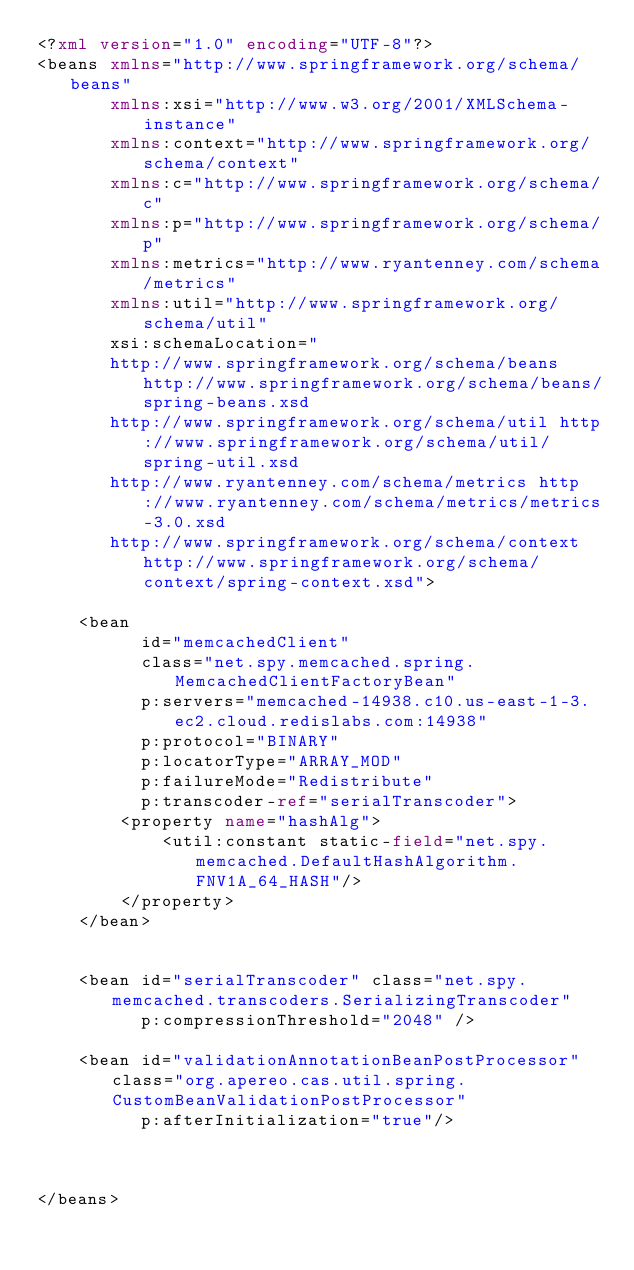Convert code to text. <code><loc_0><loc_0><loc_500><loc_500><_XML_><?xml version="1.0" encoding="UTF-8"?>
<beans xmlns="http://www.springframework.org/schema/beans"
       xmlns:xsi="http://www.w3.org/2001/XMLSchema-instance"
       xmlns:context="http://www.springframework.org/schema/context"
       xmlns:c="http://www.springframework.org/schema/c"
       xmlns:p="http://www.springframework.org/schema/p"
       xmlns:metrics="http://www.ryantenney.com/schema/metrics"
       xmlns:util="http://www.springframework.org/schema/util"
       xsi:schemaLocation="
       http://www.springframework.org/schema/beans http://www.springframework.org/schema/beans/spring-beans.xsd
       http://www.springframework.org/schema/util http://www.springframework.org/schema/util/spring-util.xsd
       http://www.ryantenney.com/schema/metrics http://www.ryantenney.com/schema/metrics/metrics-3.0.xsd
       http://www.springframework.org/schema/context http://www.springframework.org/schema/context/spring-context.xsd">
    
    <bean
          id="memcachedClient"
          class="net.spy.memcached.spring.MemcachedClientFactoryBean"
          p:servers="memcached-14938.c10.us-east-1-3.ec2.cloud.redislabs.com:14938"
          p:protocol="BINARY"
          p:locatorType="ARRAY_MOD"
          p:failureMode="Redistribute"
          p:transcoder-ref="serialTranscoder">
        <property name="hashAlg">
            <util:constant static-field="net.spy.memcached.DefaultHashAlgorithm.FNV1A_64_HASH"/>
        </property>
    </bean>


    <bean id="serialTranscoder" class="net.spy.memcached.transcoders.SerializingTranscoder"
          p:compressionThreshold="2048" />

    <bean id="validationAnnotationBeanPostProcessor" class="org.apereo.cas.util.spring.CustomBeanValidationPostProcessor"
          p:afterInitialization="true"/>
    
    
    
</beans>
</code> 